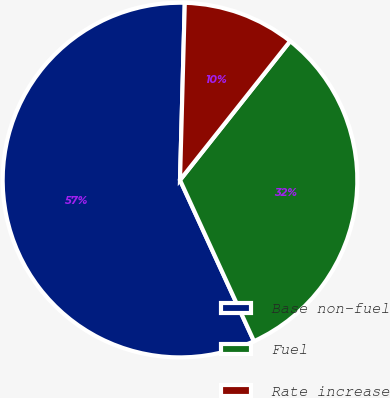Convert chart to OTSL. <chart><loc_0><loc_0><loc_500><loc_500><pie_chart><fcel>Base non-fuel<fcel>Fuel<fcel>Rate increase<nl><fcel>57.28%<fcel>32.48%<fcel>10.24%<nl></chart> 